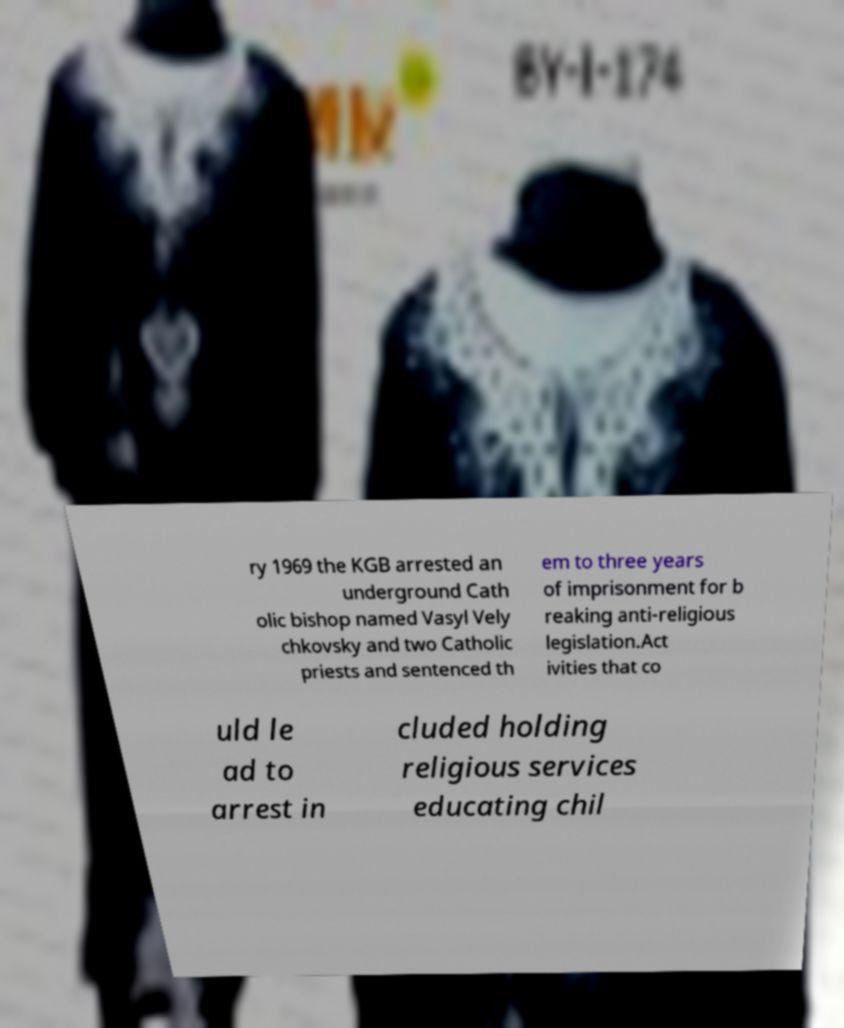What messages or text are displayed in this image? I need them in a readable, typed format. ry 1969 the KGB arrested an underground Cath olic bishop named Vasyl Vely chkovsky and two Catholic priests and sentenced th em to three years of imprisonment for b reaking anti-religious legislation.Act ivities that co uld le ad to arrest in cluded holding religious services educating chil 